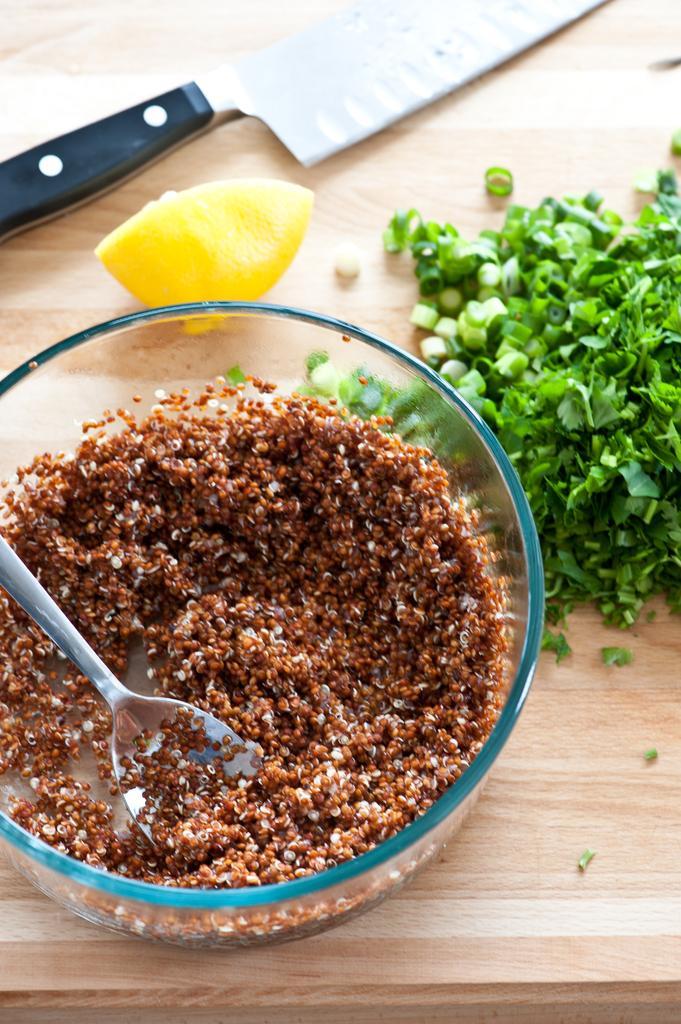How would you summarize this image in a sentence or two? This is a bowl, which contains a food item. This looks like a serving spoon. I can see the green chopped vegetables, a piece of lemon, knife and a bowl are placed on the wooden board. 